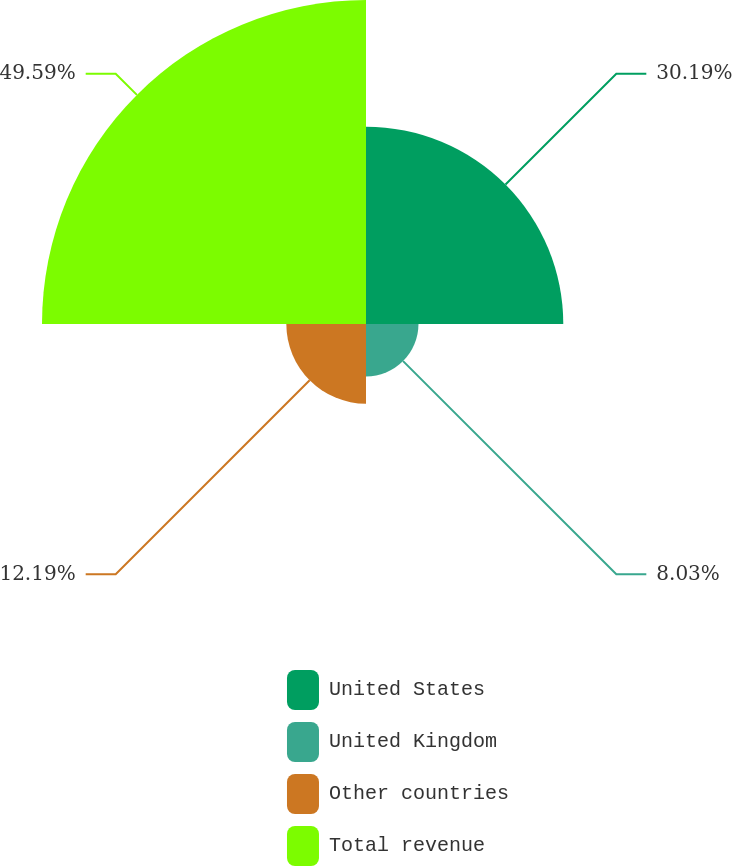Convert chart. <chart><loc_0><loc_0><loc_500><loc_500><pie_chart><fcel>United States<fcel>United Kingdom<fcel>Other countries<fcel>Total revenue<nl><fcel>30.19%<fcel>8.03%<fcel>12.19%<fcel>49.58%<nl></chart> 